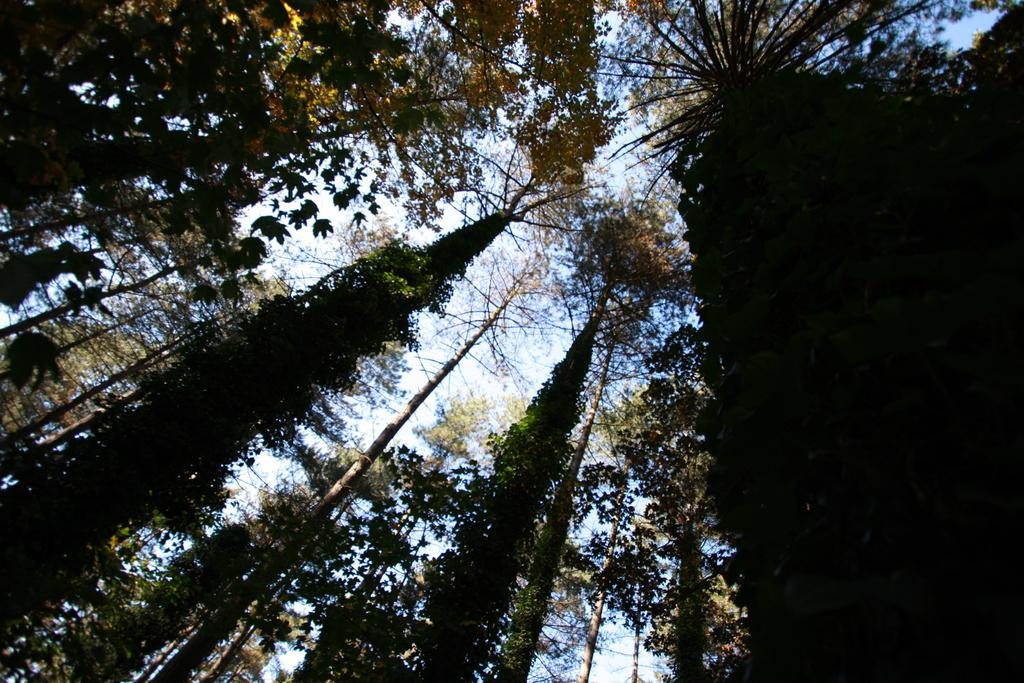What type of vegetation is present in the image? There are trees with leaves in the image. What structural components make up the trees? The trees have stems. What can be seen in the background of the image? The sky is visible in the background of the image. What type of pipe is being smoked by the dad in the image? There is no dad or pipe present in the image; it features trees with leaves and stems against a sky background. 